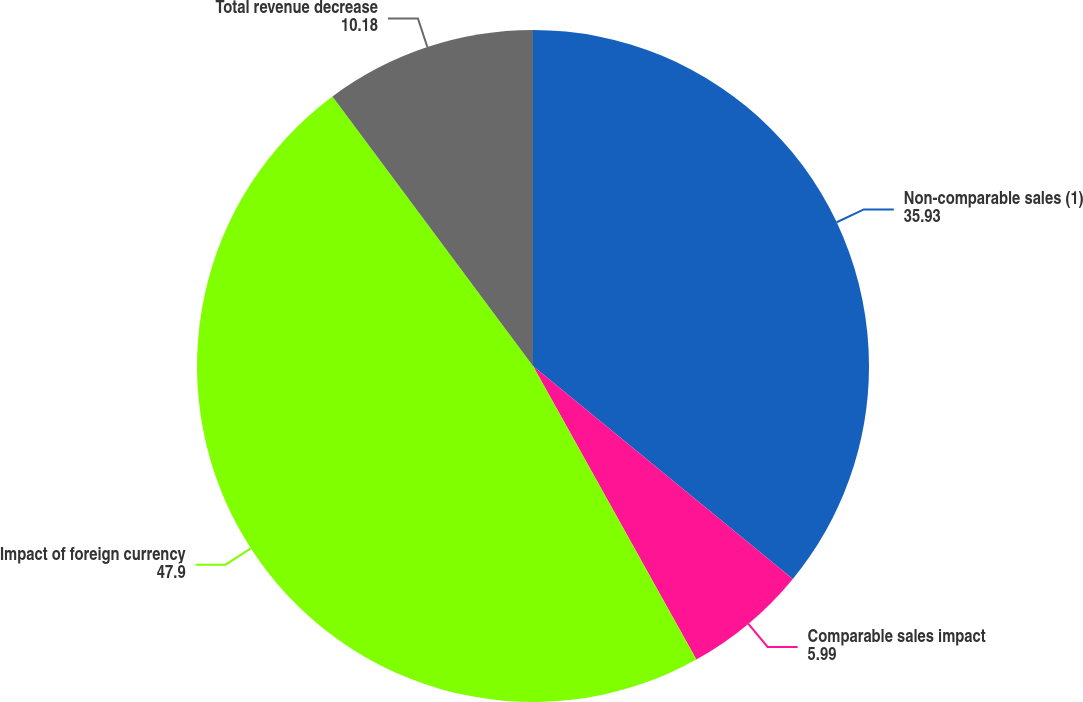Convert chart to OTSL. <chart><loc_0><loc_0><loc_500><loc_500><pie_chart><fcel>Non-comparable sales (1)<fcel>Comparable sales impact<fcel>Impact of foreign currency<fcel>Total revenue decrease<nl><fcel>35.93%<fcel>5.99%<fcel>47.9%<fcel>10.18%<nl></chart> 